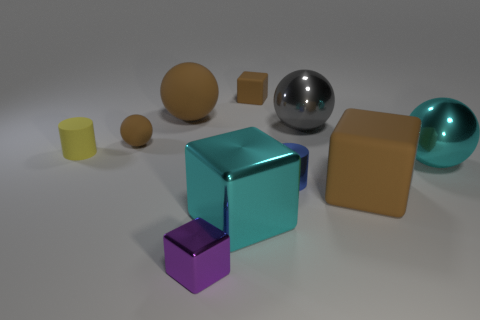Subtract 1 cubes. How many cubes are left? 3 Subtract all spheres. How many objects are left? 6 Subtract 0 red cylinders. How many objects are left? 10 Subtract all large things. Subtract all large objects. How many objects are left? 0 Add 7 small blue shiny things. How many small blue shiny things are left? 8 Add 1 tiny metallic things. How many tiny metallic things exist? 3 